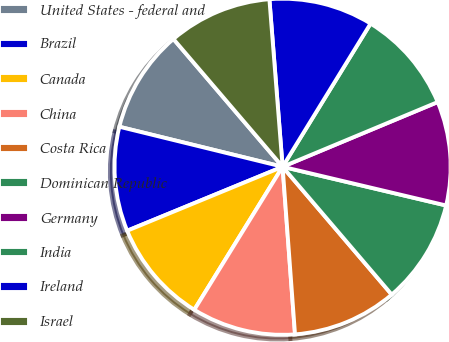<chart> <loc_0><loc_0><loc_500><loc_500><pie_chart><fcel>United States - federal and<fcel>Brazil<fcel>Canada<fcel>China<fcel>Costa Rica<fcel>Dominican Republic<fcel>Germany<fcel>India<fcel>Ireland<fcel>Israel<nl><fcel>9.92%<fcel>10.04%<fcel>9.98%<fcel>9.98%<fcel>10.07%<fcel>10.05%<fcel>9.99%<fcel>9.94%<fcel>10.02%<fcel>10.0%<nl></chart> 